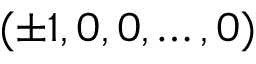Convert formula to latex. <formula><loc_0><loc_0><loc_500><loc_500>( \pm 1 , 0 , 0 , \dots , 0 )</formula> 